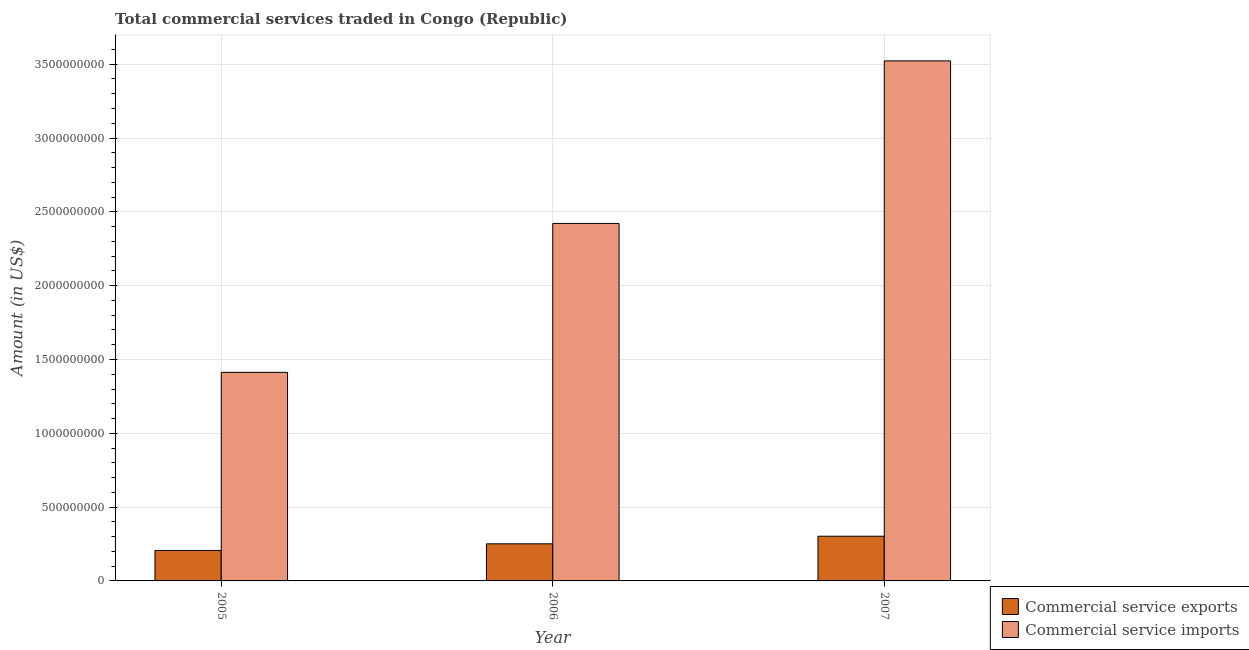How many different coloured bars are there?
Offer a very short reply. 2. How many groups of bars are there?
Ensure brevity in your answer.  3. Are the number of bars per tick equal to the number of legend labels?
Provide a short and direct response. Yes. Are the number of bars on each tick of the X-axis equal?
Provide a succinct answer. Yes. How many bars are there on the 2nd tick from the right?
Keep it short and to the point. 2. In how many cases, is the number of bars for a given year not equal to the number of legend labels?
Give a very brief answer. 0. What is the amount of commercial service imports in 2005?
Give a very brief answer. 1.41e+09. Across all years, what is the maximum amount of commercial service imports?
Offer a terse response. 3.52e+09. Across all years, what is the minimum amount of commercial service imports?
Keep it short and to the point. 1.41e+09. In which year was the amount of commercial service imports maximum?
Offer a terse response. 2007. What is the total amount of commercial service imports in the graph?
Provide a succinct answer. 7.36e+09. What is the difference between the amount of commercial service exports in 2005 and that in 2007?
Your answer should be very brief. -9.63e+07. What is the difference between the amount of commercial service exports in 2005 and the amount of commercial service imports in 2007?
Keep it short and to the point. -9.63e+07. What is the average amount of commercial service imports per year?
Provide a short and direct response. 2.45e+09. In how many years, is the amount of commercial service imports greater than 800000000 US$?
Provide a short and direct response. 3. What is the ratio of the amount of commercial service imports in 2006 to that in 2007?
Make the answer very short. 0.69. What is the difference between the highest and the second highest amount of commercial service imports?
Keep it short and to the point. 1.10e+09. What is the difference between the highest and the lowest amount of commercial service exports?
Provide a short and direct response. 9.63e+07. In how many years, is the amount of commercial service exports greater than the average amount of commercial service exports taken over all years?
Offer a terse response. 1. Is the sum of the amount of commercial service exports in 2005 and 2007 greater than the maximum amount of commercial service imports across all years?
Keep it short and to the point. Yes. What does the 2nd bar from the left in 2005 represents?
Offer a terse response. Commercial service imports. What does the 1st bar from the right in 2006 represents?
Your answer should be very brief. Commercial service imports. How many bars are there?
Your answer should be compact. 6. Are the values on the major ticks of Y-axis written in scientific E-notation?
Your answer should be compact. No. Where does the legend appear in the graph?
Give a very brief answer. Bottom right. How many legend labels are there?
Ensure brevity in your answer.  2. What is the title of the graph?
Make the answer very short. Total commercial services traded in Congo (Republic). Does "Females" appear as one of the legend labels in the graph?
Provide a succinct answer. No. What is the Amount (in US$) of Commercial service exports in 2005?
Offer a very short reply. 2.06e+08. What is the Amount (in US$) in Commercial service imports in 2005?
Your answer should be very brief. 1.41e+09. What is the Amount (in US$) of Commercial service exports in 2006?
Your answer should be compact. 2.51e+08. What is the Amount (in US$) in Commercial service imports in 2006?
Your answer should be compact. 2.42e+09. What is the Amount (in US$) in Commercial service exports in 2007?
Provide a short and direct response. 3.03e+08. What is the Amount (in US$) of Commercial service imports in 2007?
Offer a terse response. 3.52e+09. Across all years, what is the maximum Amount (in US$) in Commercial service exports?
Your response must be concise. 3.03e+08. Across all years, what is the maximum Amount (in US$) in Commercial service imports?
Provide a succinct answer. 3.52e+09. Across all years, what is the minimum Amount (in US$) of Commercial service exports?
Give a very brief answer. 2.06e+08. Across all years, what is the minimum Amount (in US$) in Commercial service imports?
Ensure brevity in your answer.  1.41e+09. What is the total Amount (in US$) of Commercial service exports in the graph?
Provide a short and direct response. 7.61e+08. What is the total Amount (in US$) of Commercial service imports in the graph?
Give a very brief answer. 7.36e+09. What is the difference between the Amount (in US$) in Commercial service exports in 2005 and that in 2006?
Your answer should be compact. -4.48e+07. What is the difference between the Amount (in US$) in Commercial service imports in 2005 and that in 2006?
Provide a succinct answer. -1.01e+09. What is the difference between the Amount (in US$) of Commercial service exports in 2005 and that in 2007?
Make the answer very short. -9.63e+07. What is the difference between the Amount (in US$) of Commercial service imports in 2005 and that in 2007?
Your answer should be very brief. -2.11e+09. What is the difference between the Amount (in US$) of Commercial service exports in 2006 and that in 2007?
Give a very brief answer. -5.15e+07. What is the difference between the Amount (in US$) in Commercial service imports in 2006 and that in 2007?
Provide a short and direct response. -1.10e+09. What is the difference between the Amount (in US$) in Commercial service exports in 2005 and the Amount (in US$) in Commercial service imports in 2006?
Your answer should be compact. -2.22e+09. What is the difference between the Amount (in US$) of Commercial service exports in 2005 and the Amount (in US$) of Commercial service imports in 2007?
Provide a succinct answer. -3.32e+09. What is the difference between the Amount (in US$) of Commercial service exports in 2006 and the Amount (in US$) of Commercial service imports in 2007?
Your answer should be compact. -3.27e+09. What is the average Amount (in US$) of Commercial service exports per year?
Your answer should be compact. 2.54e+08. What is the average Amount (in US$) of Commercial service imports per year?
Offer a terse response. 2.45e+09. In the year 2005, what is the difference between the Amount (in US$) of Commercial service exports and Amount (in US$) of Commercial service imports?
Offer a very short reply. -1.21e+09. In the year 2006, what is the difference between the Amount (in US$) in Commercial service exports and Amount (in US$) in Commercial service imports?
Your answer should be compact. -2.17e+09. In the year 2007, what is the difference between the Amount (in US$) of Commercial service exports and Amount (in US$) of Commercial service imports?
Offer a very short reply. -3.22e+09. What is the ratio of the Amount (in US$) in Commercial service exports in 2005 to that in 2006?
Your answer should be compact. 0.82. What is the ratio of the Amount (in US$) in Commercial service imports in 2005 to that in 2006?
Your answer should be compact. 0.58. What is the ratio of the Amount (in US$) in Commercial service exports in 2005 to that in 2007?
Your response must be concise. 0.68. What is the ratio of the Amount (in US$) of Commercial service imports in 2005 to that in 2007?
Make the answer very short. 0.4. What is the ratio of the Amount (in US$) of Commercial service exports in 2006 to that in 2007?
Your response must be concise. 0.83. What is the ratio of the Amount (in US$) in Commercial service imports in 2006 to that in 2007?
Keep it short and to the point. 0.69. What is the difference between the highest and the second highest Amount (in US$) in Commercial service exports?
Provide a short and direct response. 5.15e+07. What is the difference between the highest and the second highest Amount (in US$) in Commercial service imports?
Keep it short and to the point. 1.10e+09. What is the difference between the highest and the lowest Amount (in US$) in Commercial service exports?
Your answer should be very brief. 9.63e+07. What is the difference between the highest and the lowest Amount (in US$) of Commercial service imports?
Give a very brief answer. 2.11e+09. 